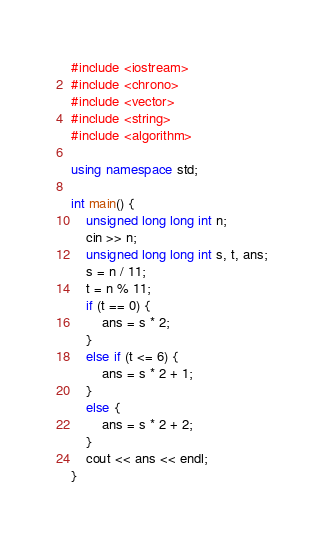<code> <loc_0><loc_0><loc_500><loc_500><_C++_>#include <iostream>
#include <chrono>
#include <vector>
#include <string>
#include <algorithm>

using namespace std;

int main() {
	unsigned long long int n;
	cin >> n;
	unsigned long long int s, t, ans;
	s = n / 11;
	t = n % 11;
	if (t == 0) {
		ans = s * 2;
	}
	else if (t <= 6) {
		ans = s * 2 + 1;
	}
	else {
		ans = s * 2 + 2;
	}
	cout << ans << endl;
}

</code> 